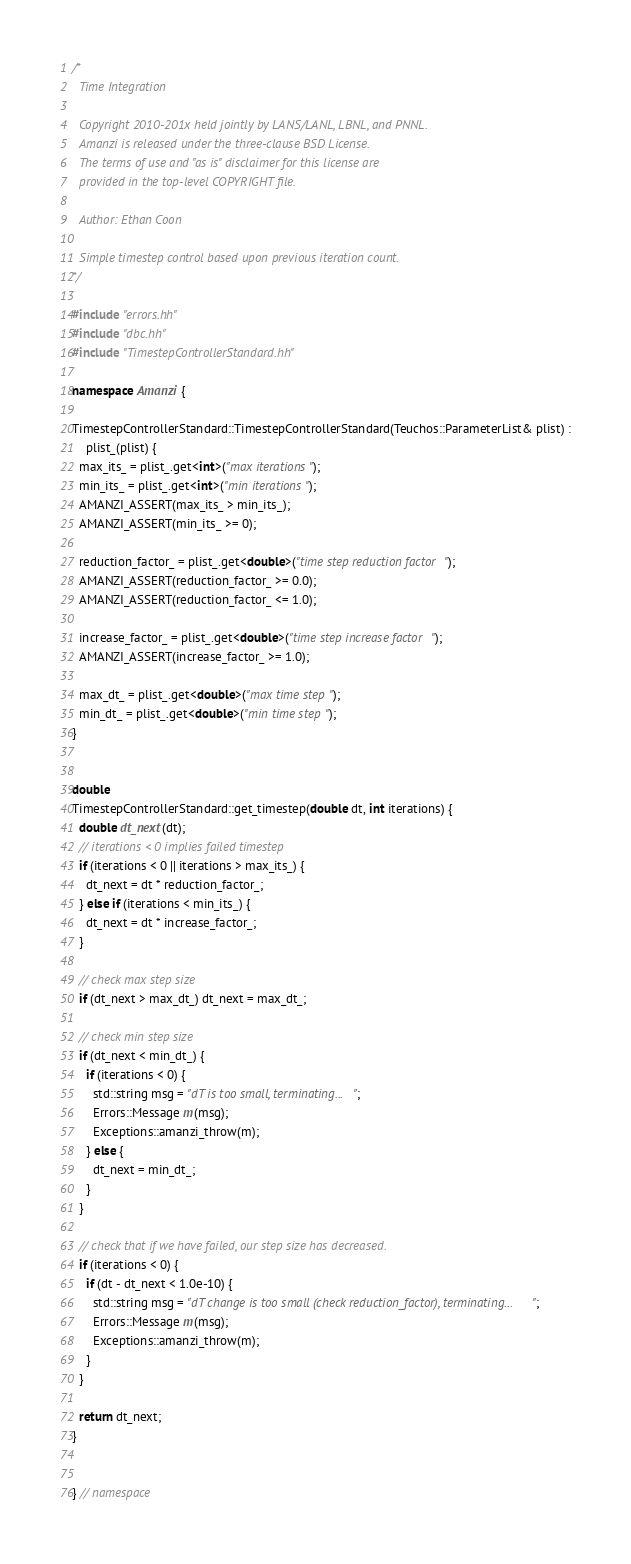Convert code to text. <code><loc_0><loc_0><loc_500><loc_500><_C++_>/*
  Time Integration

  Copyright 2010-201x held jointly by LANS/LANL, LBNL, and PNNL. 
  Amanzi is released under the three-clause BSD License. 
  The terms of use and "as is" disclaimer for this license are 
  provided in the top-level COPYRIGHT file.

  Author: Ethan Coon

  Simple timestep control based upon previous iteration count.
*/

#include "errors.hh"
#include "dbc.hh"
#include "TimestepControllerStandard.hh"

namespace Amanzi {

TimestepControllerStandard::TimestepControllerStandard(Teuchos::ParameterList& plist) :
    plist_(plist) {
  max_its_ = plist_.get<int>("max iterations");
  min_its_ = plist_.get<int>("min iterations");
  AMANZI_ASSERT(max_its_ > min_its_);
  AMANZI_ASSERT(min_its_ >= 0);

  reduction_factor_ = plist_.get<double>("time step reduction factor");
  AMANZI_ASSERT(reduction_factor_ >= 0.0);
  AMANZI_ASSERT(reduction_factor_ <= 1.0);

  increase_factor_ = plist_.get<double>("time step increase factor");
  AMANZI_ASSERT(increase_factor_ >= 1.0);

  max_dt_ = plist_.get<double>("max time step");
  min_dt_ = plist_.get<double>("min time step");
}


double
TimestepControllerStandard::get_timestep(double dt, int iterations) {
  double dt_next(dt);
  // iterations < 0 implies failed timestep
  if (iterations < 0 || iterations > max_its_) {
    dt_next = dt * reduction_factor_;
  } else if (iterations < min_its_) {
    dt_next = dt * increase_factor_;
  }

  // check max step size
  if (dt_next > max_dt_) dt_next = max_dt_;

  // check min step size
  if (dt_next < min_dt_) {
    if (iterations < 0) {
      std::string msg = "dT is too small, terminating...";
      Errors::Message m(msg);
      Exceptions::amanzi_throw(m);
    } else {
      dt_next = min_dt_;
    }
  }

  // check that if we have failed, our step size has decreased.
  if (iterations < 0) {
    if (dt - dt_next < 1.0e-10) {
      std::string msg = "dT change is too small (check reduction_factor), terminating...";
      Errors::Message m(msg);
      Exceptions::amanzi_throw(m);
    }
  }

  return dt_next;
}


} // namespace
</code> 